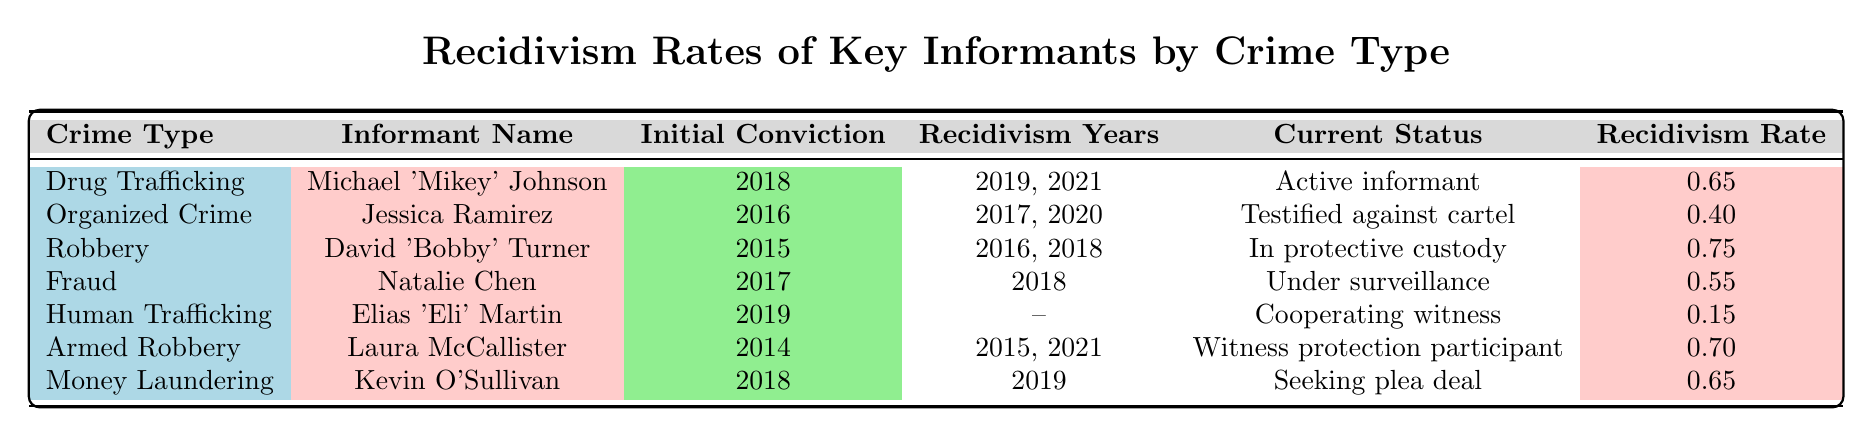What is the recidivism rate for Michael 'Mikey' Johnson? The recidivism rate for Michael 'Mikey' Johnson is provided in the table next to his name in the "Recidivism Rate" column. It shows a rate of 0.65.
Answer: 0.65 Which informant has the highest recidivism rate and what is it? The highest recidivism rate is found in the row for David 'Bobby' Turner, which shows a rate of 0.75.
Answer: David 'Bobby' Turner, 0.75 How many years did Laura McCallister recidivate after her initial conviction year of 2014? Laura McCallister recidivated in 2015 and 2021, which means she recidivated twice in the years following her initial conviction of 2014.
Answer: 2 years Is the statement "Elias 'Eli' Martin has recidivated more than once" true? Elias 'Eli' Martin has no recorded recidivism years in the table, therefore the statement is false.
Answer: False What is the average recidivism rate among all informants listed? To calculate the average, sum all the recidivism rates: (0.65 + 0.40 + 0.75 + 0.55 + 0.15 + 0.70 + 0.65) = 3.95. There are 7 informants, so divide 3.95 by 7, which gives approximately 0.566.
Answer: 0.566 Which crime type has the lowest recidivism rate and what is the rate? By examining the data, Human Trafficking has the lowest recidivism rate at 0.15 compared to all other rates in the table.
Answer: Human Trafficking, 0.15 How many informants have a recidivism rate of 0.65? Both Michael 'Mikey' Johnson and Kevin O'Sullivan have a recidivism rate of 0.65, therefore there are two informants with this rate.
Answer: 2 informants Was Jessica Ramirez's current status "Active informant"? The table indicates that Jessica Ramirez's current status is "Testified against cartel," which means the statement is false.
Answer: False How many informants have initially been convicted before 2017? By checking the "Initial Conviction" column, the informants with convictions before 2017 are Laura McCallister (2014), David 'Bobby' Turner (2015), and Jessica Ramirez (2016). That makes 3 informants in total.
Answer: 3 informants 